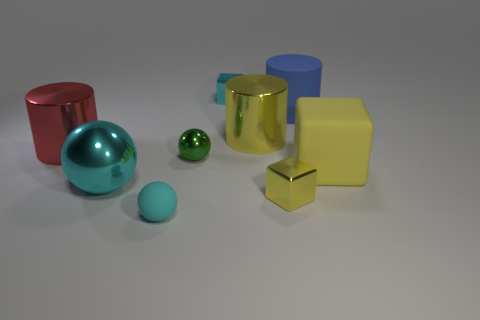Add 1 large red metallic cylinders. How many objects exist? 10 Subtract all blocks. How many objects are left? 6 Add 6 tiny gray metallic things. How many tiny gray metallic things exist? 6 Subtract 1 red cylinders. How many objects are left? 8 Subtract all large gray cylinders. Subtract all yellow shiny blocks. How many objects are left? 8 Add 4 tiny rubber spheres. How many tiny rubber spheres are left? 5 